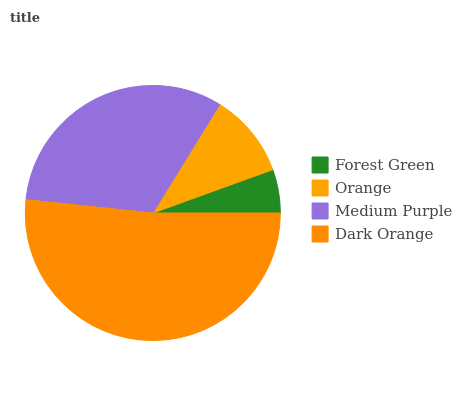Is Forest Green the minimum?
Answer yes or no. Yes. Is Dark Orange the maximum?
Answer yes or no. Yes. Is Orange the minimum?
Answer yes or no. No. Is Orange the maximum?
Answer yes or no. No. Is Orange greater than Forest Green?
Answer yes or no. Yes. Is Forest Green less than Orange?
Answer yes or no. Yes. Is Forest Green greater than Orange?
Answer yes or no. No. Is Orange less than Forest Green?
Answer yes or no. No. Is Medium Purple the high median?
Answer yes or no. Yes. Is Orange the low median?
Answer yes or no. Yes. Is Forest Green the high median?
Answer yes or no. No. Is Dark Orange the low median?
Answer yes or no. No. 